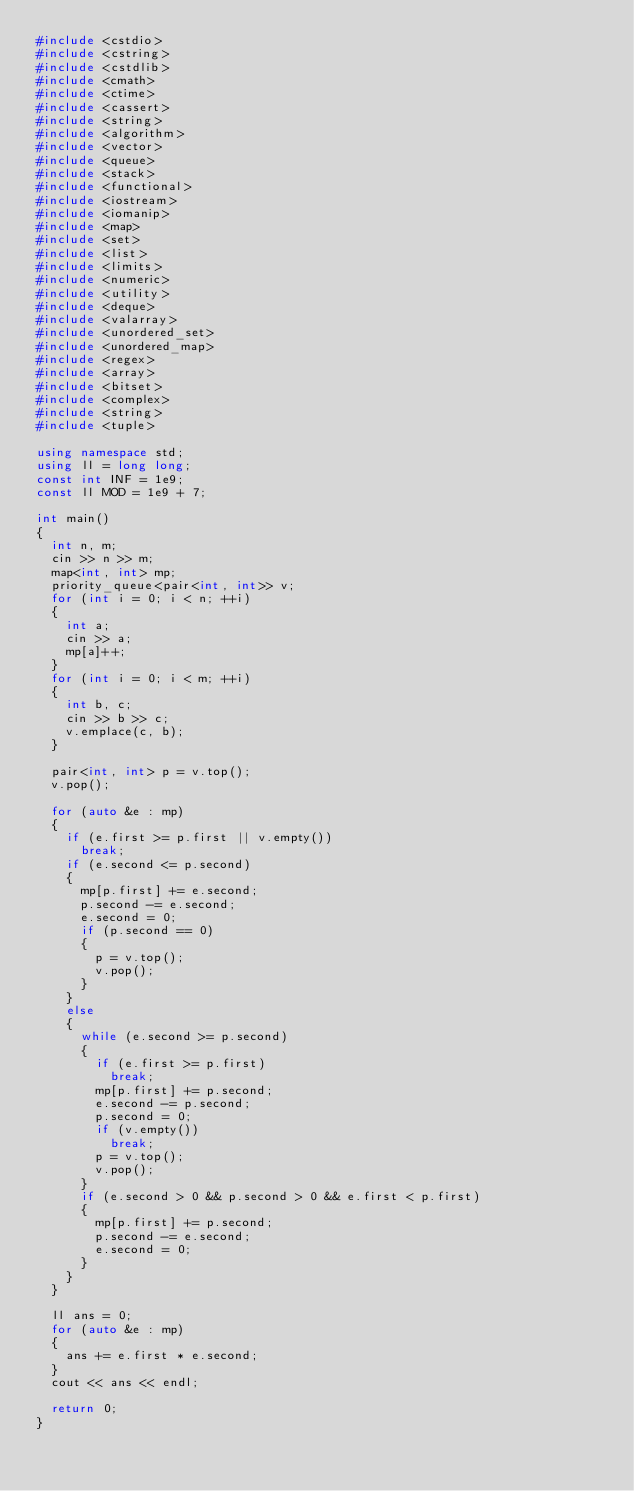<code> <loc_0><loc_0><loc_500><loc_500><_C++_>#include <cstdio>
#include <cstring>
#include <cstdlib>
#include <cmath>
#include <ctime>
#include <cassert>
#include <string>
#include <algorithm>
#include <vector>
#include <queue>
#include <stack>
#include <functional>
#include <iostream>
#include <iomanip>
#include <map>
#include <set>
#include <list>
#include <limits>
#include <numeric>
#include <utility>
#include <deque>
#include <valarray>
#include <unordered_set>
#include <unordered_map>
#include <regex>
#include <array>
#include <bitset>
#include <complex>
#include <string>
#include <tuple>

using namespace std;
using ll = long long;
const int INF = 1e9;
const ll MOD = 1e9 + 7;

int main()
{
  int n, m;
  cin >> n >> m;
  map<int, int> mp;
  priority_queue<pair<int, int>> v;
  for (int i = 0; i < n; ++i)
  {
    int a;
    cin >> a;
    mp[a]++;
  }
  for (int i = 0; i < m; ++i)
  {
    int b, c;
    cin >> b >> c;
    v.emplace(c, b);
  }

  pair<int, int> p = v.top();
  v.pop();

  for (auto &e : mp)
  {
    if (e.first >= p.first || v.empty())
      break;
    if (e.second <= p.second)
    {
      mp[p.first] += e.second;
      p.second -= e.second;
      e.second = 0;
      if (p.second == 0)
      {
        p = v.top();
        v.pop();
      }
    }
    else
    {
      while (e.second >= p.second)
      {
        if (e.first >= p.first)
          break;
        mp[p.first] += p.second;
        e.second -= p.second;
        p.second = 0;
        if (v.empty())
          break;
        p = v.top();
        v.pop();
      }
      if (e.second > 0 && p.second > 0 && e.first < p.first)
      {
        mp[p.first] += p.second;
        p.second -= e.second;
        e.second = 0;
      }
    }
  }

  ll ans = 0;
  for (auto &e : mp)
  {
    ans += e.first * e.second;
  }
  cout << ans << endl;

  return 0;
}
</code> 